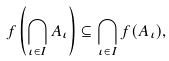<formula> <loc_0><loc_0><loc_500><loc_500>f \left ( \bigcap _ { \iota \in I } A _ { \iota } \right ) \subseteq \bigcap _ { \iota \in I } f ( A _ { \iota } ) ,</formula> 